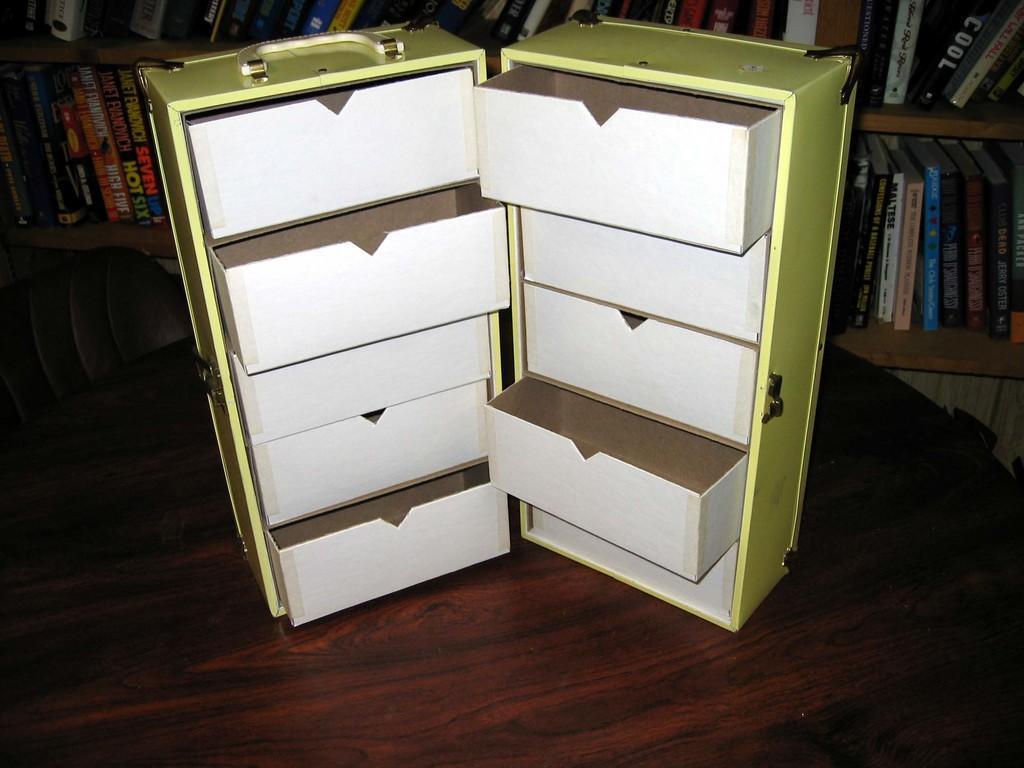Please provide a concise description of this image. Here there is a box with racks in it on a table. In the background there is a chair and books in the book shelves. 